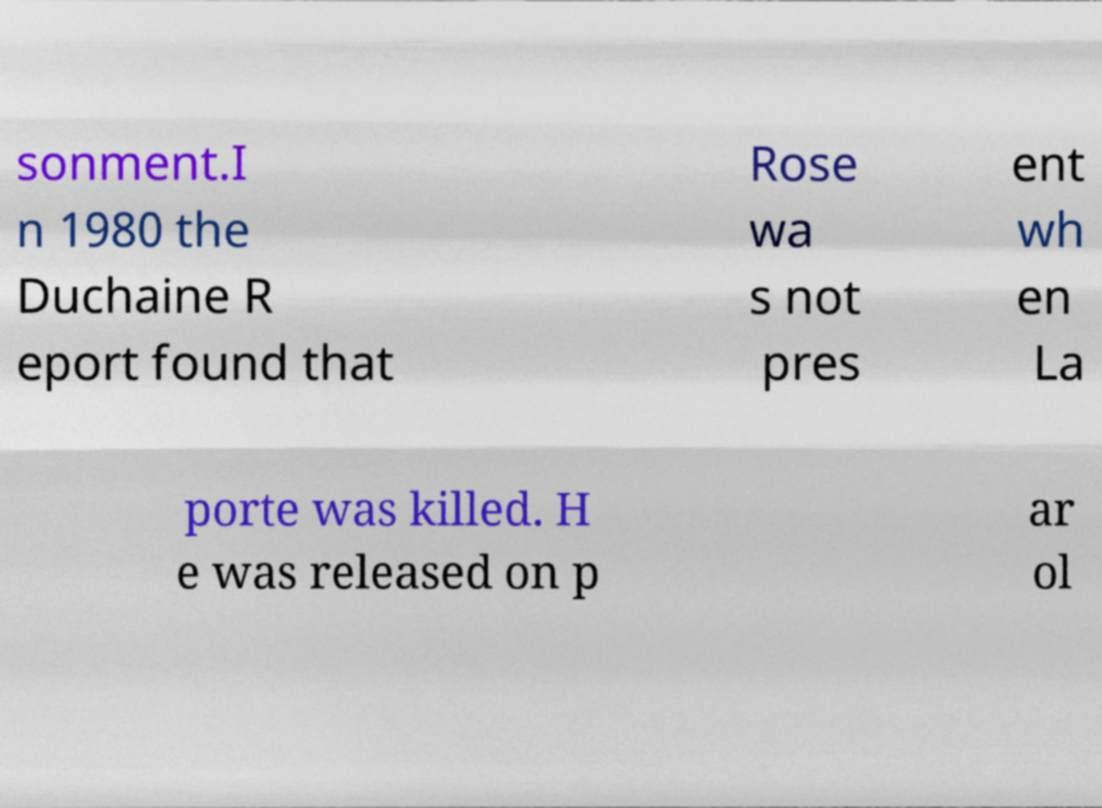Please identify and transcribe the text found in this image. sonment.I n 1980 the Duchaine R eport found that Rose wa s not pres ent wh en La porte was killed. H e was released on p ar ol 